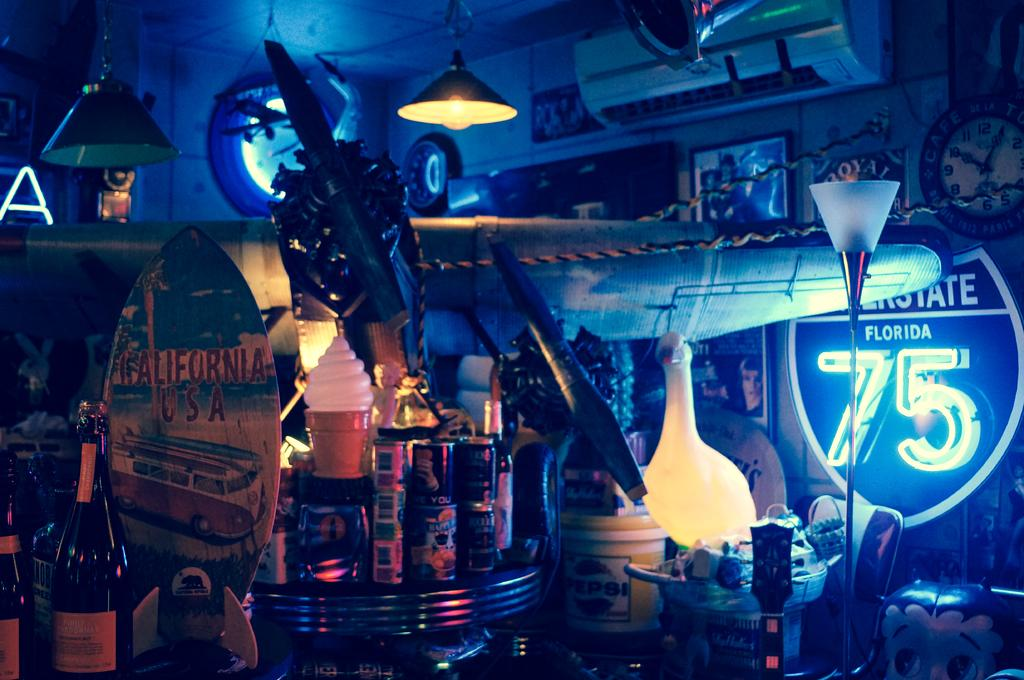<image>
Share a concise interpretation of the image provided. a blue light with the number 75 on it 